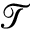Convert formula to latex. <formula><loc_0><loc_0><loc_500><loc_500>\mathcal { T }</formula> 